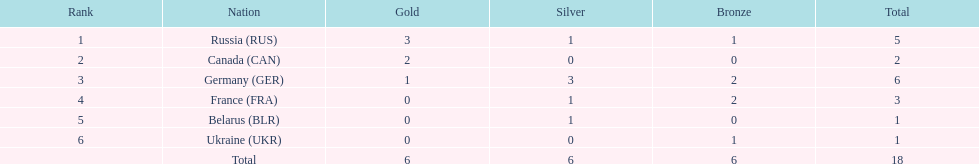What country had the most medals total at the the 1994 winter olympics biathlon? Germany (GER). 